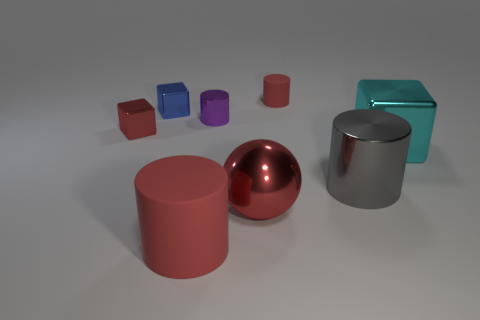There is a shiny cylinder that is to the right of the big red metallic object; how many gray things are in front of it?
Make the answer very short. 0. There is a tiny cylinder that is the same color as the big metal ball; what material is it?
Your response must be concise. Rubber. What number of other objects are there of the same color as the big metal sphere?
Provide a succinct answer. 3. The small cylinder that is on the right side of the large ball in front of the red block is what color?
Give a very brief answer. Red. Is there a matte cylinder that has the same color as the sphere?
Your answer should be compact. Yes. What number of shiny objects are either cyan things or tiny cubes?
Ensure brevity in your answer.  3. Are there any yellow objects made of the same material as the large ball?
Provide a short and direct response. No. How many things are both left of the large cyan metal block and behind the big red matte cylinder?
Offer a very short reply. 6. Is the number of big red matte cylinders that are to the left of the large gray thing less than the number of tiny blue things that are in front of the big rubber thing?
Give a very brief answer. No. Is the big red rubber object the same shape as the tiny blue object?
Give a very brief answer. No. 